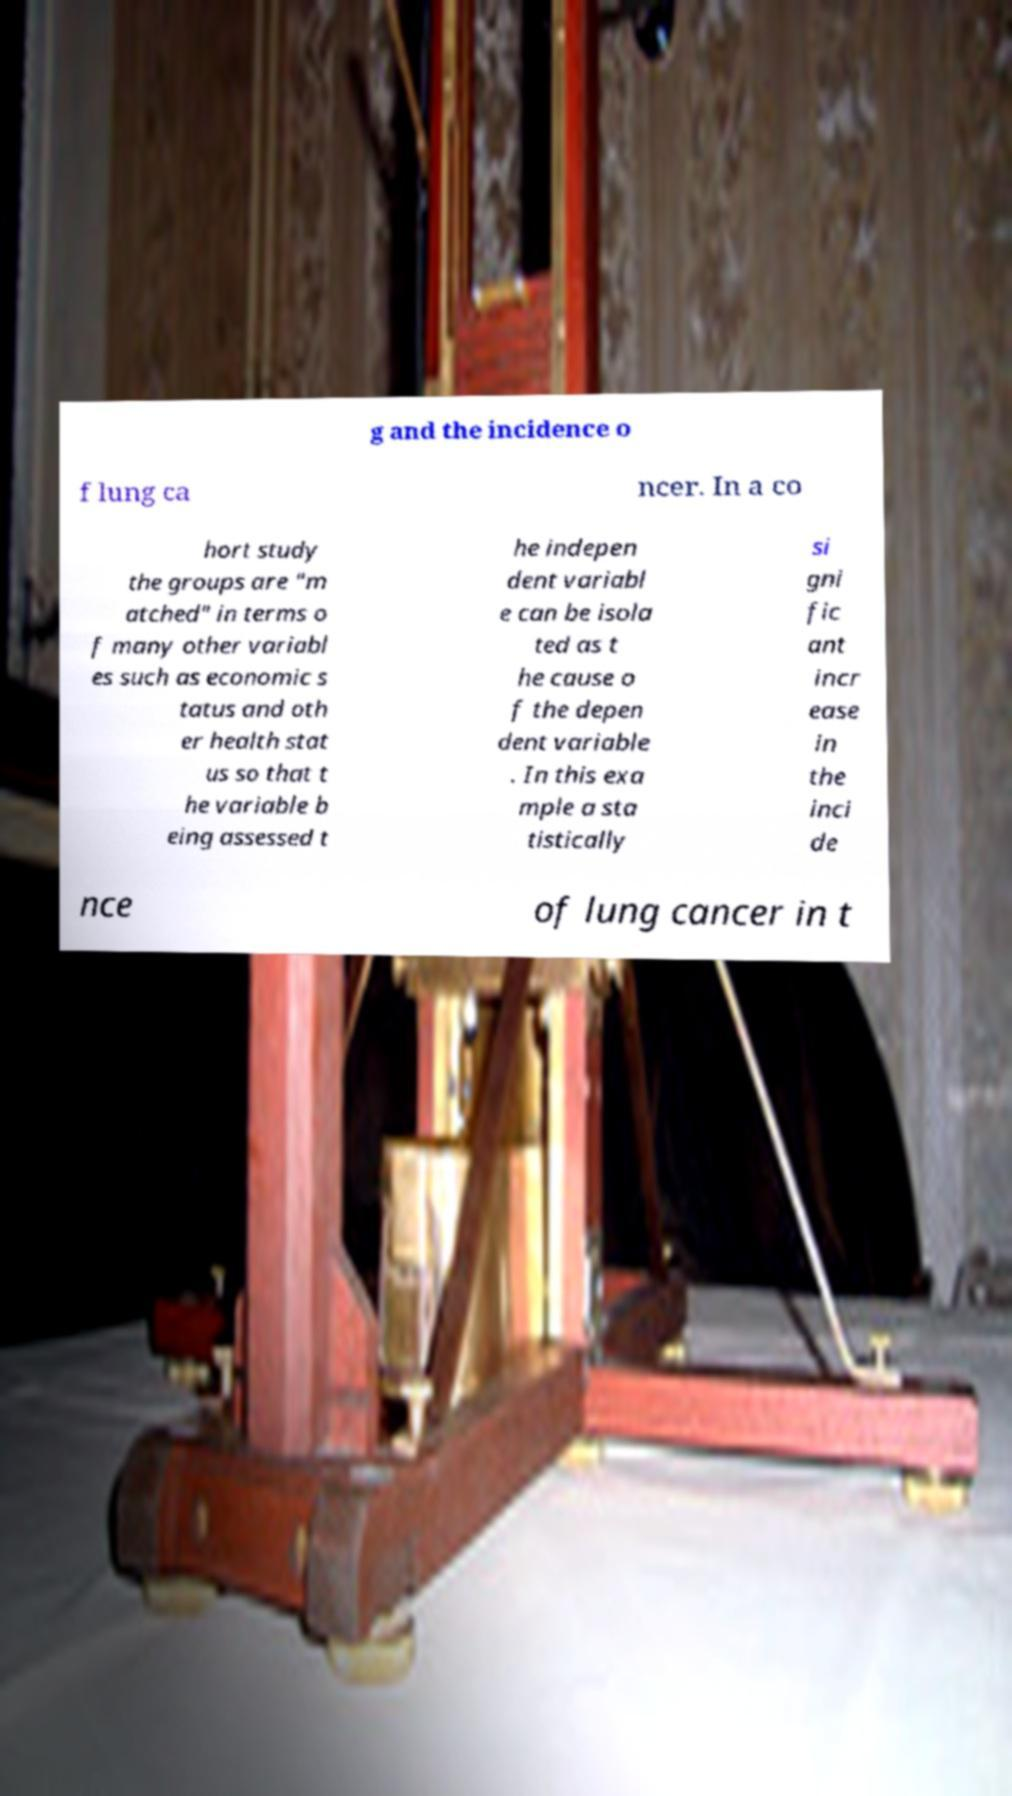Can you read and provide the text displayed in the image?This photo seems to have some interesting text. Can you extract and type it out for me? g and the incidence o f lung ca ncer. In a co hort study the groups are "m atched" in terms o f many other variabl es such as economic s tatus and oth er health stat us so that t he variable b eing assessed t he indepen dent variabl e can be isola ted as t he cause o f the depen dent variable . In this exa mple a sta tistically si gni fic ant incr ease in the inci de nce of lung cancer in t 